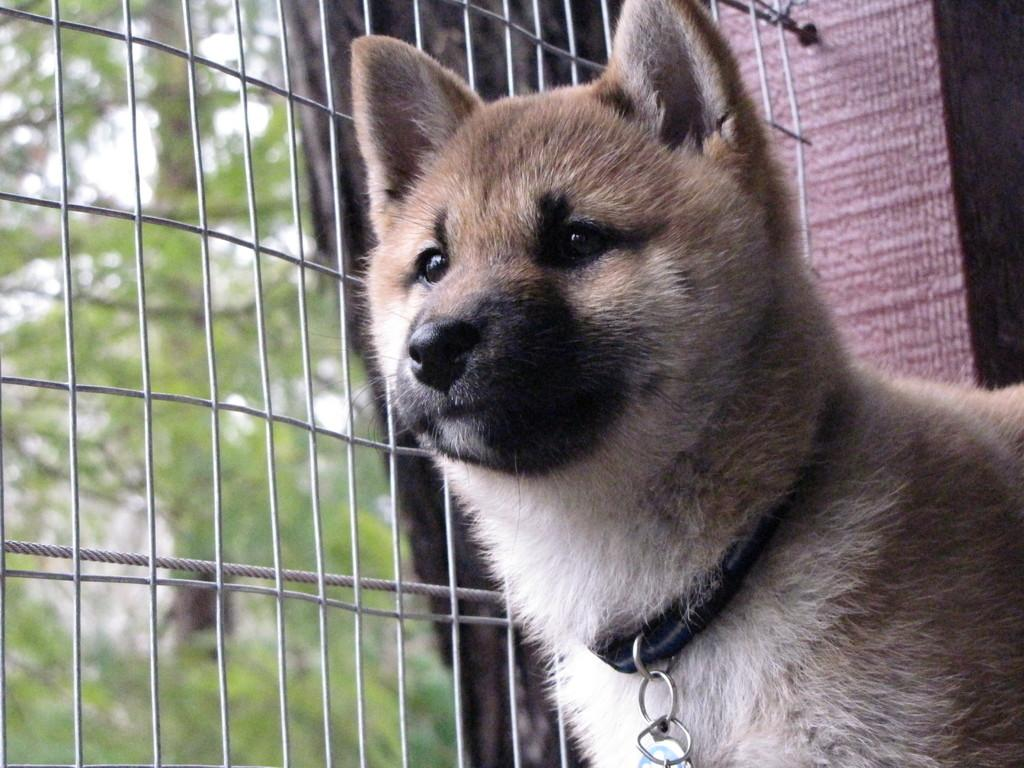What type of animal is in the image? There is a dog in the image. What is the dog wearing? The dog is wearing a black belt. What can be found on the ground in the image? There is an object on the ground in the image. What type of structure is in the image? There is a fence attached to a wall in the image. What type of vegetation is in the image? There are trees on the ground in the image. What flavor of ice cream is the dog holding in the image? There is no ice cream present in the image; the dog is wearing a black belt. Can you see a lamp in the image? There is no lamp present in the image. 